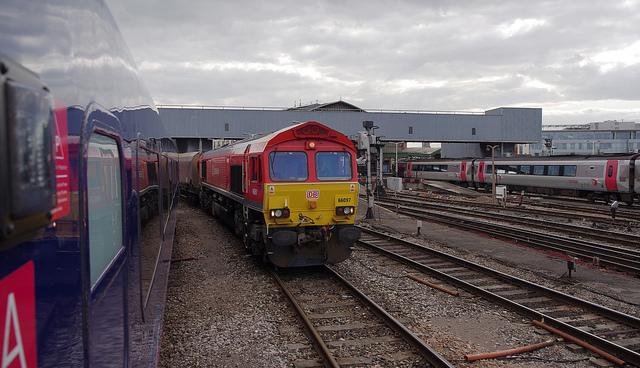What is the weather like in this photo?
Concise answer only. Cloudy. Where is this train stopped?
Give a very brief answer. Station. How many train tracks are there?
Give a very brief answer. 5. How many train cars are easily visible?
Short answer required. 4. What is the purple thing on the left?
Quick response, please. Train. What letter do you see?
Short answer required. A. What pattern is displayed on the front of the train?
Give a very brief answer. Triangle. What does the weather look like in this photo?
Short answer required. Cloudy. 